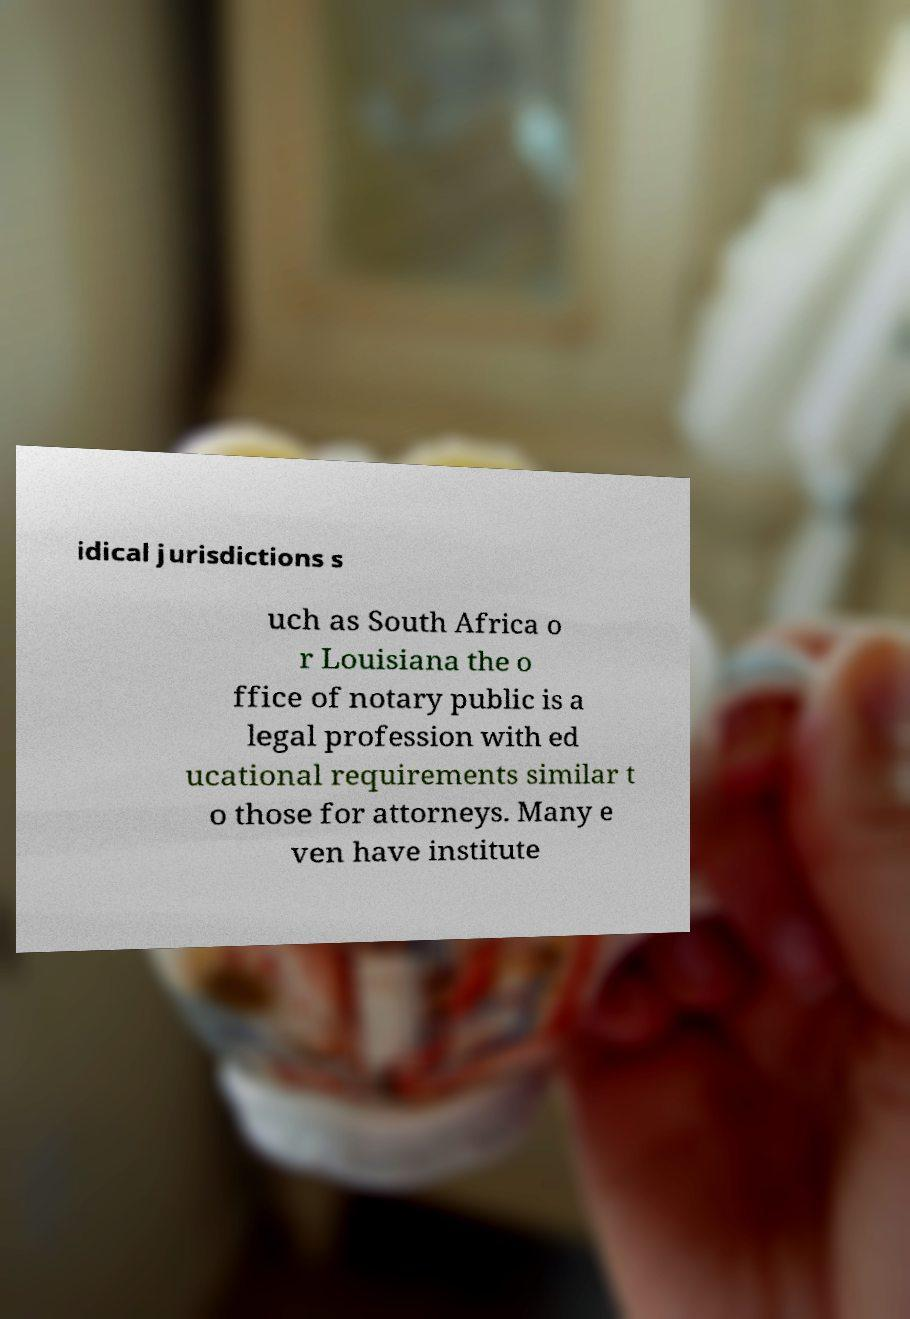Can you read and provide the text displayed in the image?This photo seems to have some interesting text. Can you extract and type it out for me? idical jurisdictions s uch as South Africa o r Louisiana the o ffice of notary public is a legal profession with ed ucational requirements similar t o those for attorneys. Many e ven have institute 